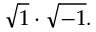Convert formula to latex. <formula><loc_0><loc_0><loc_500><loc_500>{ \sqrt { 1 } } \cdot { \sqrt { - 1 } } .</formula> 